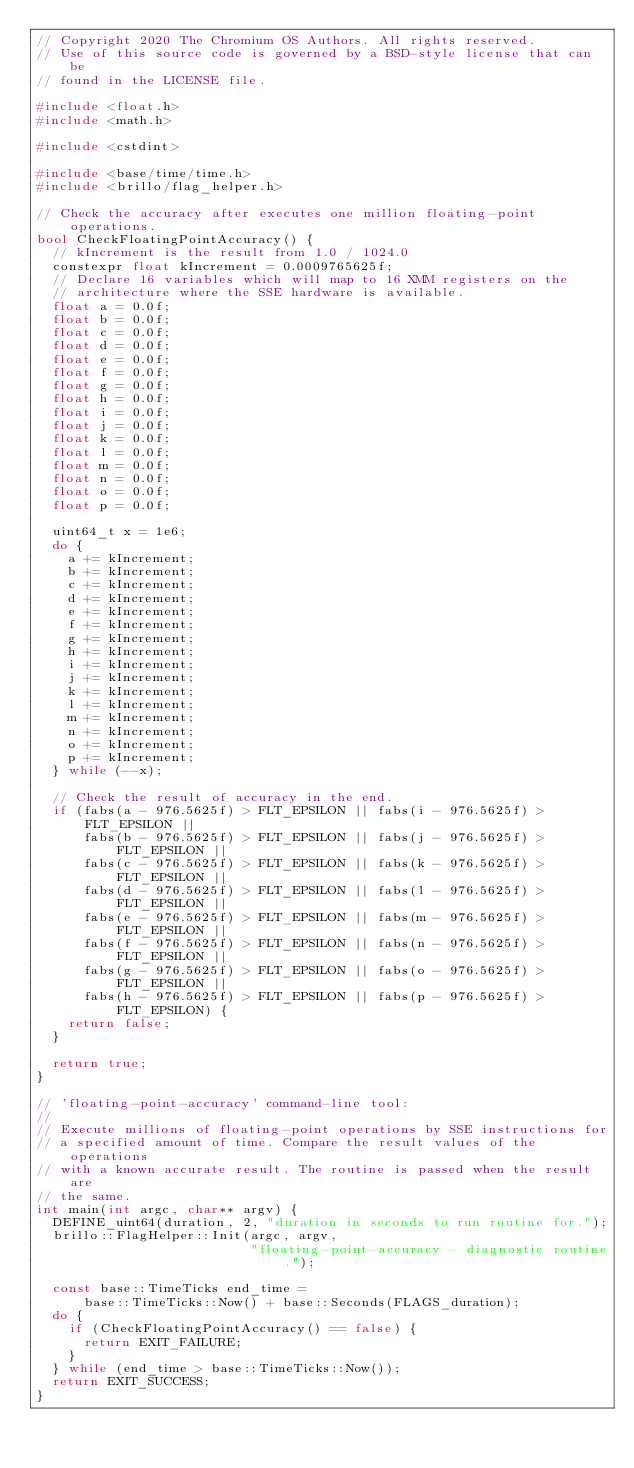<code> <loc_0><loc_0><loc_500><loc_500><_C++_>// Copyright 2020 The Chromium OS Authors. All rights reserved.
// Use of this source code is governed by a BSD-style license that can be
// found in the LICENSE file.

#include <float.h>
#include <math.h>

#include <cstdint>

#include <base/time/time.h>
#include <brillo/flag_helper.h>

// Check the accuracy after executes one million floating-point operations.
bool CheckFloatingPointAccuracy() {
  // kIncrement is the result from 1.0 / 1024.0
  constexpr float kIncrement = 0.0009765625f;
  // Declare 16 variables which will map to 16 XMM registers on the
  // architecture where the SSE hardware is available.
  float a = 0.0f;
  float b = 0.0f;
  float c = 0.0f;
  float d = 0.0f;
  float e = 0.0f;
  float f = 0.0f;
  float g = 0.0f;
  float h = 0.0f;
  float i = 0.0f;
  float j = 0.0f;
  float k = 0.0f;
  float l = 0.0f;
  float m = 0.0f;
  float n = 0.0f;
  float o = 0.0f;
  float p = 0.0f;

  uint64_t x = 1e6;
  do {
    a += kIncrement;
    b += kIncrement;
    c += kIncrement;
    d += kIncrement;
    e += kIncrement;
    f += kIncrement;
    g += kIncrement;
    h += kIncrement;
    i += kIncrement;
    j += kIncrement;
    k += kIncrement;
    l += kIncrement;
    m += kIncrement;
    n += kIncrement;
    o += kIncrement;
    p += kIncrement;
  } while (--x);

  // Check the result of accuracy in the end.
  if (fabs(a - 976.5625f) > FLT_EPSILON || fabs(i - 976.5625f) > FLT_EPSILON ||
      fabs(b - 976.5625f) > FLT_EPSILON || fabs(j - 976.5625f) > FLT_EPSILON ||
      fabs(c - 976.5625f) > FLT_EPSILON || fabs(k - 976.5625f) > FLT_EPSILON ||
      fabs(d - 976.5625f) > FLT_EPSILON || fabs(l - 976.5625f) > FLT_EPSILON ||
      fabs(e - 976.5625f) > FLT_EPSILON || fabs(m - 976.5625f) > FLT_EPSILON ||
      fabs(f - 976.5625f) > FLT_EPSILON || fabs(n - 976.5625f) > FLT_EPSILON ||
      fabs(g - 976.5625f) > FLT_EPSILON || fabs(o - 976.5625f) > FLT_EPSILON ||
      fabs(h - 976.5625f) > FLT_EPSILON || fabs(p - 976.5625f) > FLT_EPSILON) {
    return false;
  }

  return true;
}

// 'floating-point-accuracy' command-line tool:
//
// Execute millions of floating-point operations by SSE instructions for
// a specified amount of time. Compare the result values of the operations
// with a known accurate result. The routine is passed when the result are
// the same.
int main(int argc, char** argv) {
  DEFINE_uint64(duration, 2, "duration in seconds to run routine for.");
  brillo::FlagHelper::Init(argc, argv,
                           "floating-point-accuracy - diagnostic routine.");

  const base::TimeTicks end_time =
      base::TimeTicks::Now() + base::Seconds(FLAGS_duration);
  do {
    if (CheckFloatingPointAccuracy() == false) {
      return EXIT_FAILURE;
    }
  } while (end_time > base::TimeTicks::Now());
  return EXIT_SUCCESS;
}
</code> 